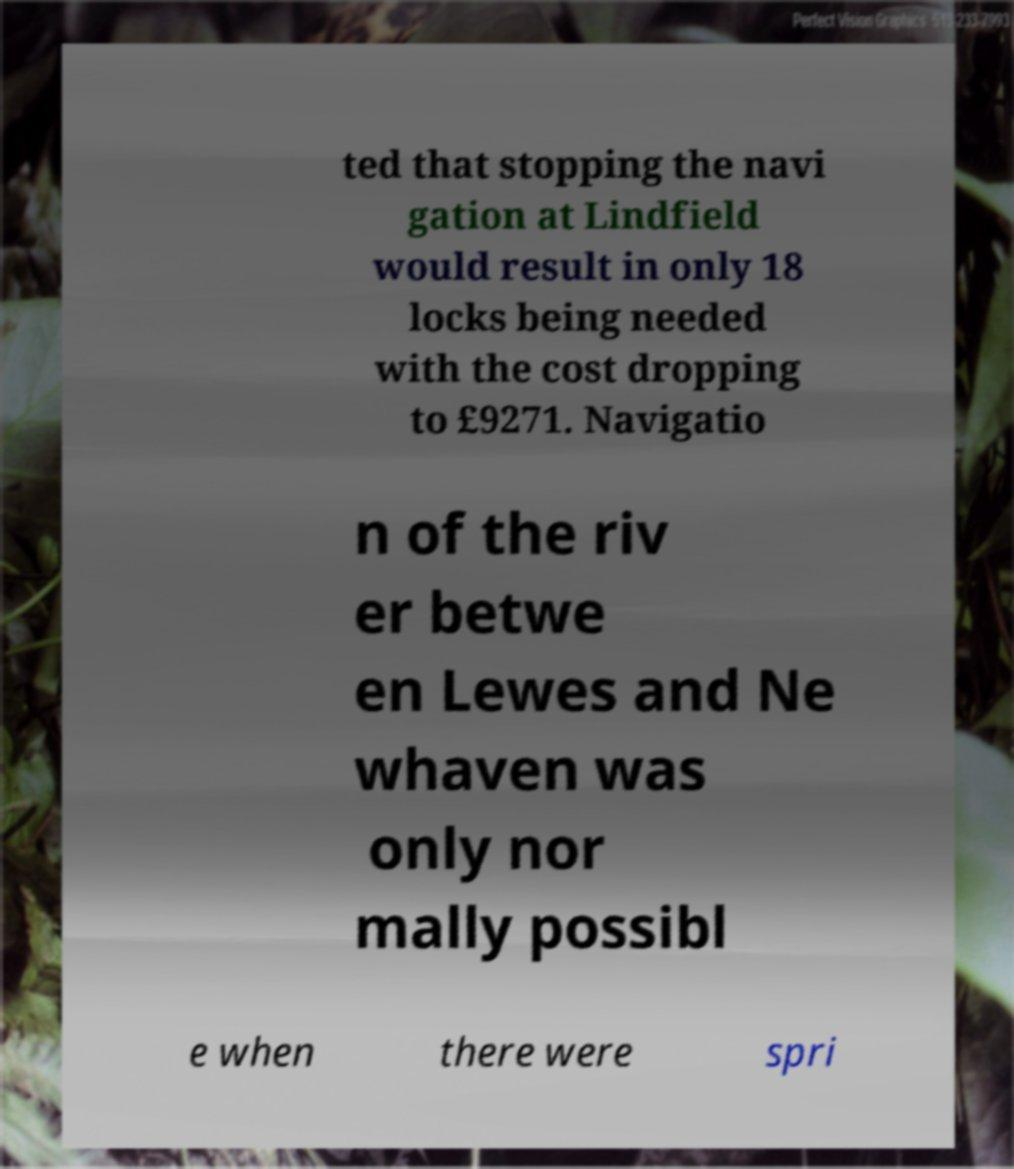Please identify and transcribe the text found in this image. ted that stopping the navi gation at Lindfield would result in only 18 locks being needed with the cost dropping to £9271. Navigatio n of the riv er betwe en Lewes and Ne whaven was only nor mally possibl e when there were spri 